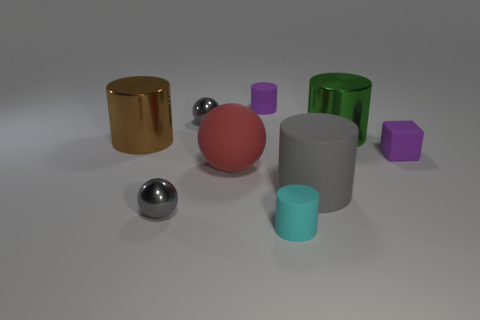There is a small gray object in front of the big matte sphere; is it the same shape as the big green metal thing? no 